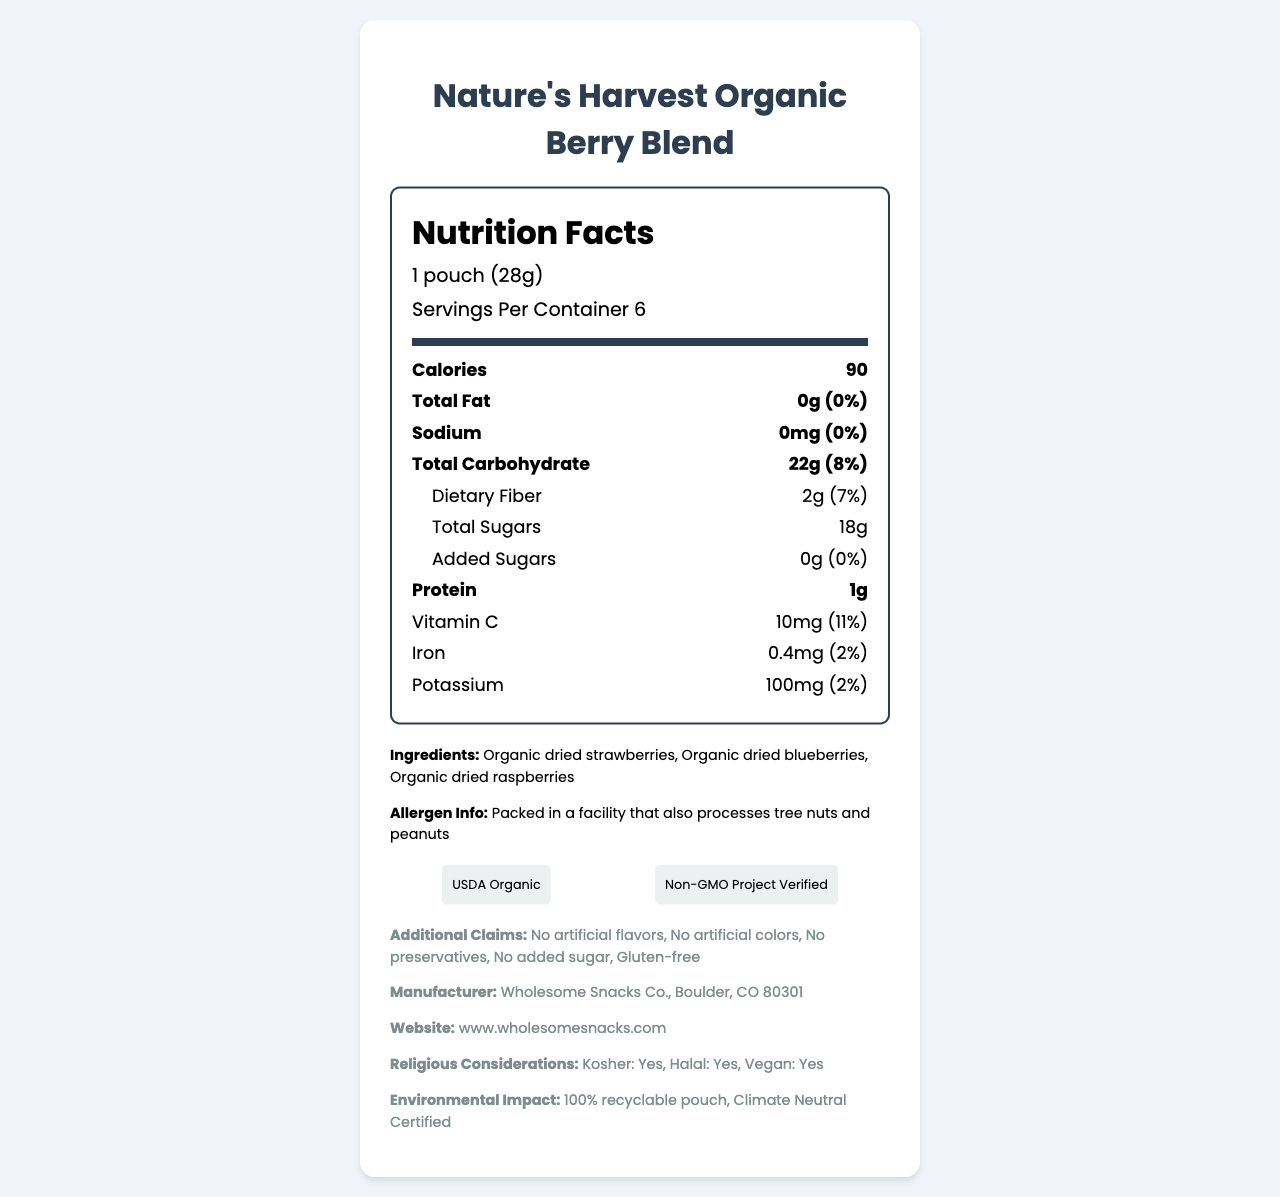what is the serving size? The serving size is explicitly mentioned as "1 pouch (28g)" in the document.
Answer: 1 pouch (28g) how many calories are in each serving? The document lists the calories per serving as 90.
Answer: 90 list three ingredients in the product The ingredients section lists three ingredients: Organic dried strawberries, Organic dried blueberries, and Organic dried raspberries.
Answer: Organic dried strawberries, Organic dried blueberries, Organic dried raspberries is there any added sugar in this fruit snack? The document states under "Total Sugars" that the amount of "Added Sugars" is 0g (0% Daily Value).
Answer: No can people with tree nut allergies consume this product safely? The allergen info mentions that the product is packed in a facility that also processes tree nuts and peanuts, indicating a risk of cross-contamination.
Answer: No what percentages of Vitamin C and Iron are in a serving? The document lists Vitamin C at 10mg (11% Daily Value) and Iron at 0.4mg (2% Daily Value) per serving.
Answer: 11% (Vitamin C) and 2% (Iron) which certification is not attributed to this product? A. USDA Organic B. Fair Trade Certified C. Non-GMO Project Verified The document mentions "USDA Organic" and "Non-GMO Project Verified" but does not mention "Fair Trade Certified."
Answer: B what is the total amount of potassium per serving? A. 50mg B. 75mg C. 100mg D. 200mg The total amount of potassium per serving is 100mg.
Answer: C is this product gluten-free? The document includes an additional claim that the product is gluten-free.
Answer: Yes does the product have any artificial additives? The document states multiple claims, such as "No artificial flavors," "No artificial colors," and "No preservatives."
Answer: No can you summarize the main idea of the document? The document outlines the specific nutritional content, including calories, vitamins, and minerals, as well as the absence of added sugars and artificial additives. It also lists certifications like USDA Organic and Non-GMO Project Verified, and claims about the product being gluten-free and vegan.
Answer: The document provides the nutrition facts, ingredients, certifications, and additional claims for "Nature's Harvest Organic Berry Blend," highlighting its organic ingredients, lack of artificial additives, and gluten-free status. how many different dried berries are used as ingredients in the product? The ingredients listed in the document are organic dried strawberries, organic dried blueberries, and organic dried raspberries, making three different dried berries.
Answer: 3 what is the carbon footprint certification for this product? The environmental impact section mentions that the product has a "Climate Neutral Certified" carbon footprint.
Answer: Climate Neutral Certified where is the manufacturer located? A. New York, NY B. Boulder, CO C. San Francisco, CA D. Austin, TX The document specifies that the manufacturer, Wholesome Snacks Co., is located in Boulder, CO 80301.
Answer: B what is the protein content per serving? The document lists the protein content per serving as 1g.
Answer: 1g does the document provide information about the price of the product? The document does not include any details about the price.
Answer: Not enough information who manufactures "Nature's Harvest Organic Berry Blend"? The manufacturer information section lists Wholesome Snacks Co. as the manufacturer of the product.
Answer: Wholesome Snacks Co. 